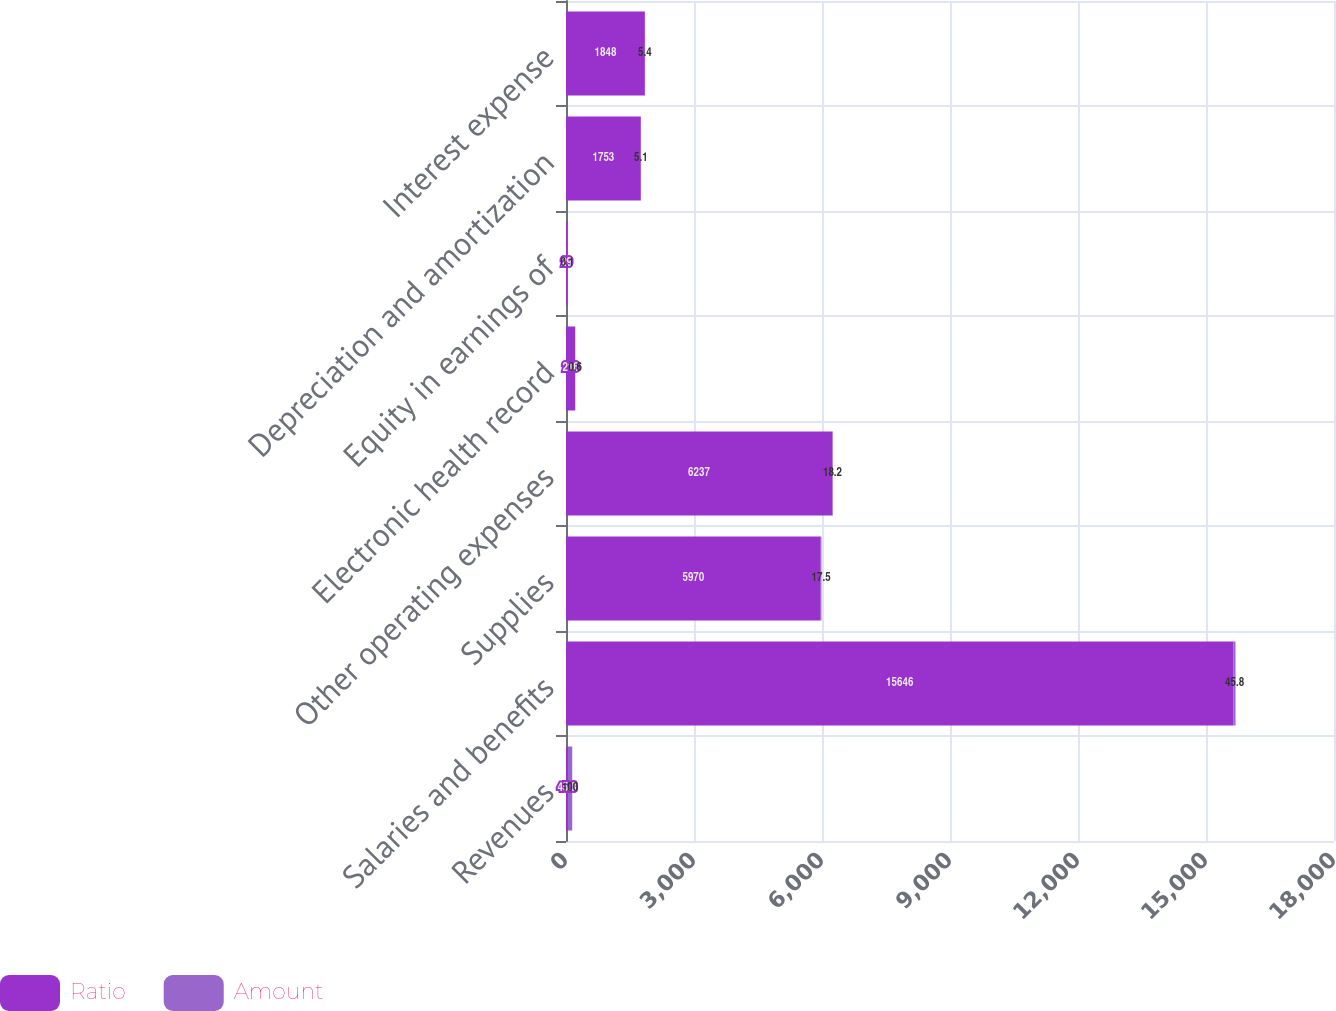Convert chart to OTSL. <chart><loc_0><loc_0><loc_500><loc_500><stacked_bar_chart><ecel><fcel>Revenues<fcel>Salaries and benefits<fcel>Supplies<fcel>Other operating expenses<fcel>Electronic health record<fcel>Equity in earnings of<fcel>Depreciation and amortization<fcel>Interest expense<nl><fcel>Ratio<fcel>45.8<fcel>15646<fcel>5970<fcel>6237<fcel>216<fcel>29<fcel>1753<fcel>1848<nl><fcel>Amount<fcel>100<fcel>45.8<fcel>17.5<fcel>18.2<fcel>0.6<fcel>0.1<fcel>5.1<fcel>5.4<nl></chart> 